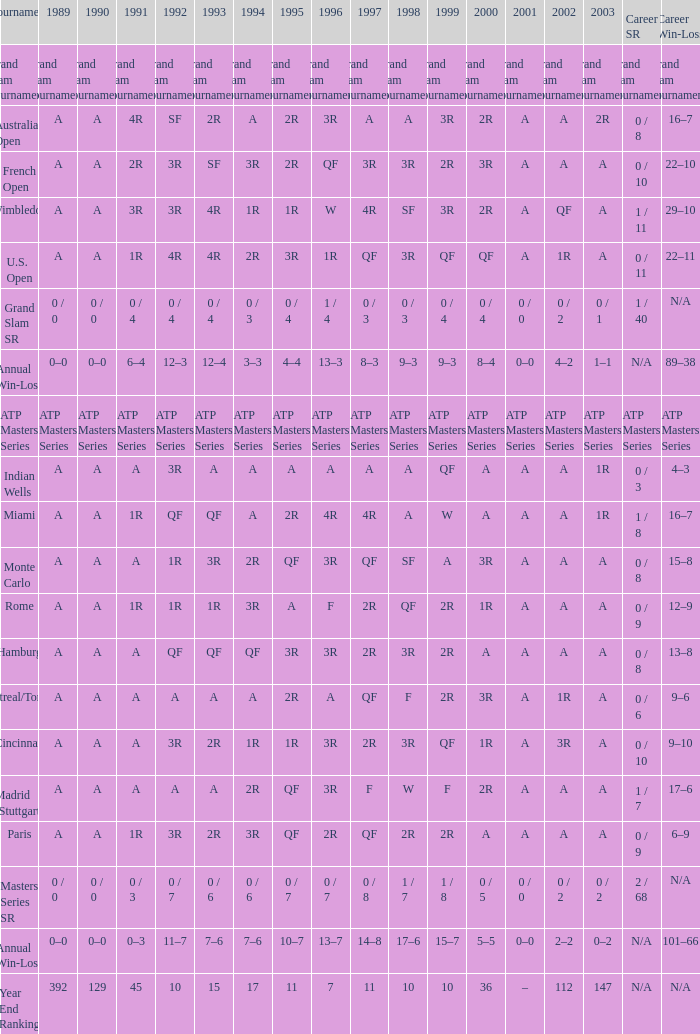What was the value in 1997 if the values in 1989, 1995, and 1996 were a, qf, and 3r, respectively, and the career sr is 0/8? QF. 